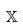Convert formula to latex. <formula><loc_0><loc_0><loc_500><loc_500>\mathbb { X }</formula> 